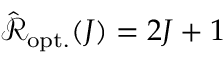Convert formula to latex. <formula><loc_0><loc_0><loc_500><loc_500>\hat { \mathcal { R } } _ { o p t . } ( J ) = 2 J + 1</formula> 